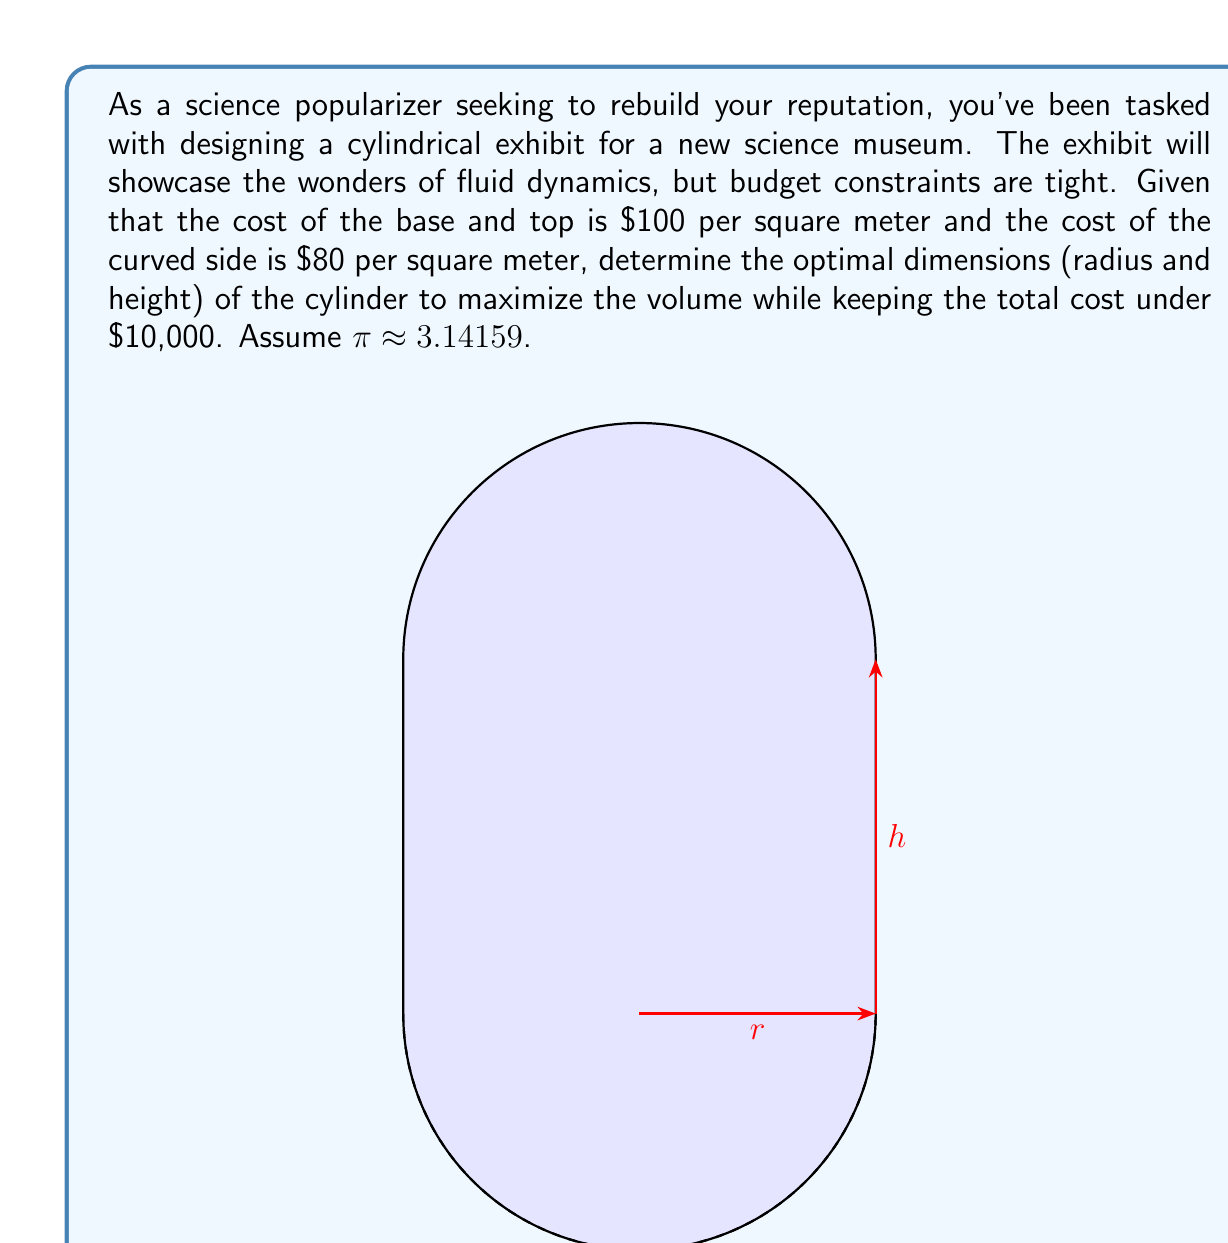Teach me how to tackle this problem. Let's approach this step-by-step:

1) Let $r$ be the radius and $h$ be the height of the cylinder.

2) The volume of the cylinder is given by:
   $$V = πr^2h$$

3) The surface area of the cylinder consists of two circular bases and the curved side:
   - Area of bases: $2πr^2$
   - Area of curved side: $2πrh$

4) The total cost function is:
   $$C = 100(2πr^2) + 80(2πrh) = 200πr^2 + 160πrh$$

5) Our constraint is that the cost should be less than or equal to $10,000:
   $$200πr^2 + 160πrh ≤ 10000$$

6) We want to maximize the volume subject to this constraint. This is a constrained optimization problem that can be solved using the method of Lagrange multipliers.

7) Let's form the Lagrangian:
   $$L = πr^2h + λ(200πr^2 + 160πrh - 10000)$$

8) Taking partial derivatives and setting them to zero:
   $$\frac{∂L}{∂r} = 2πrh + λ(400πr + 160πh) = 0$$
   $$\frac{∂L}{∂h} = πr^2 + λ(160πr) = 0$$
   $$\frac{∂L}{∂λ} = 200πr^2 + 160πrh - 10000 = 0$$

9) From the second equation:
   $$λ = -\frac{r}{160}$$

10) Substituting this into the first equation:
    $$2πrh - \frac{r}{160}(400πr + 160πh) = 0$$
    $$320πrh = 400πr^2 + 160πrh$$
    $$160πrh = 400πr^2$$
    $$h = \frac{5r}{2}$$

11) Substituting this into the constraint equation:
    $$200πr^2 + 160πr(\frac{5r}{2}) = 10000$$
    $$200πr^2 + 400πr^2 = 10000$$
    $$600πr^2 = 10000$$
    $$r^2 = \frac{10000}{600π} ≈ 5.305$$
    $$r ≈ 2.303$$

12) And consequently:
    $$h = \frac{5r}{2} ≈ 5.758$$

13) We can verify that these dimensions indeed maximize the volume by checking the second derivatives, which is left as an exercise.
Answer: $r ≈ 2.303$ m, $h ≈ 5.758$ m 